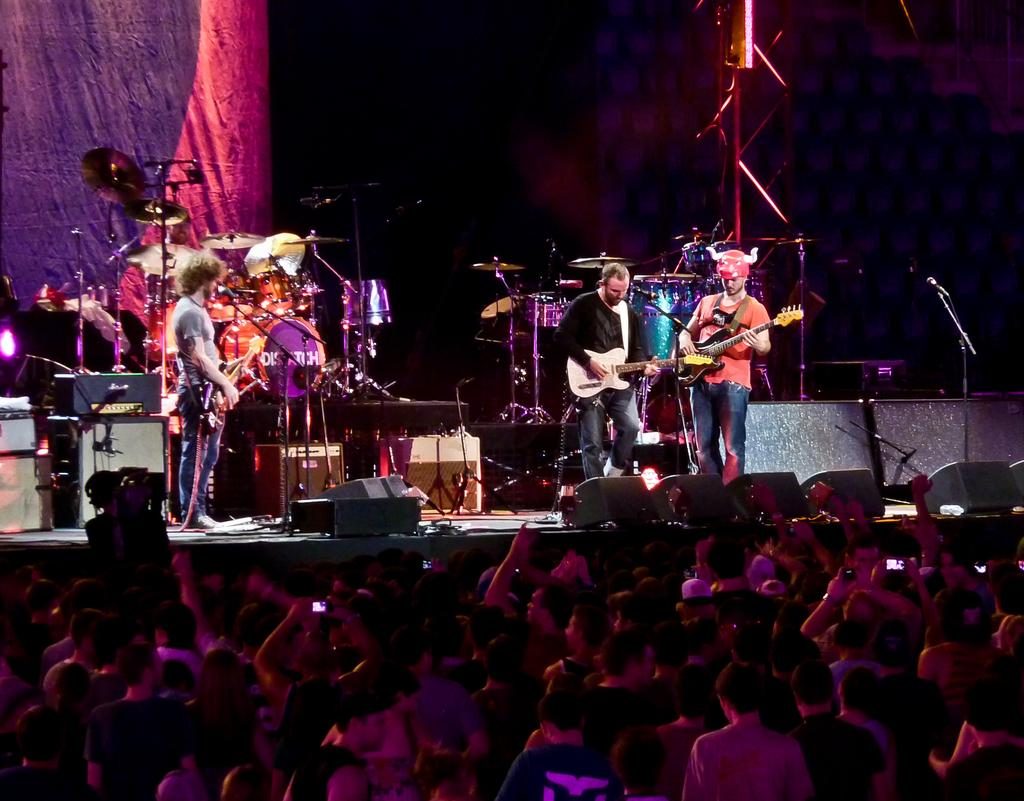How many musicians are playing in the image? There are three people playing musical instruments in the image. What are the musicians doing? The musicians are playing their instruments. Can you describe the audience in front of the musicians? There is a group of people in front of the musicians. What type of copper material is being used by the musicians in the image? There is no mention of copper or any specific material used by the musicians in the image. 